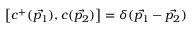Convert formula to latex. <formula><loc_0><loc_0><loc_500><loc_500>\left [ c ^ { + } ( \vec { p _ { 1 } } ) , c ( \vec { p _ { 2 } } ) \right ] = \delta ( \vec { p _ { 1 } } - \vec { p _ { 2 } } )</formula> 